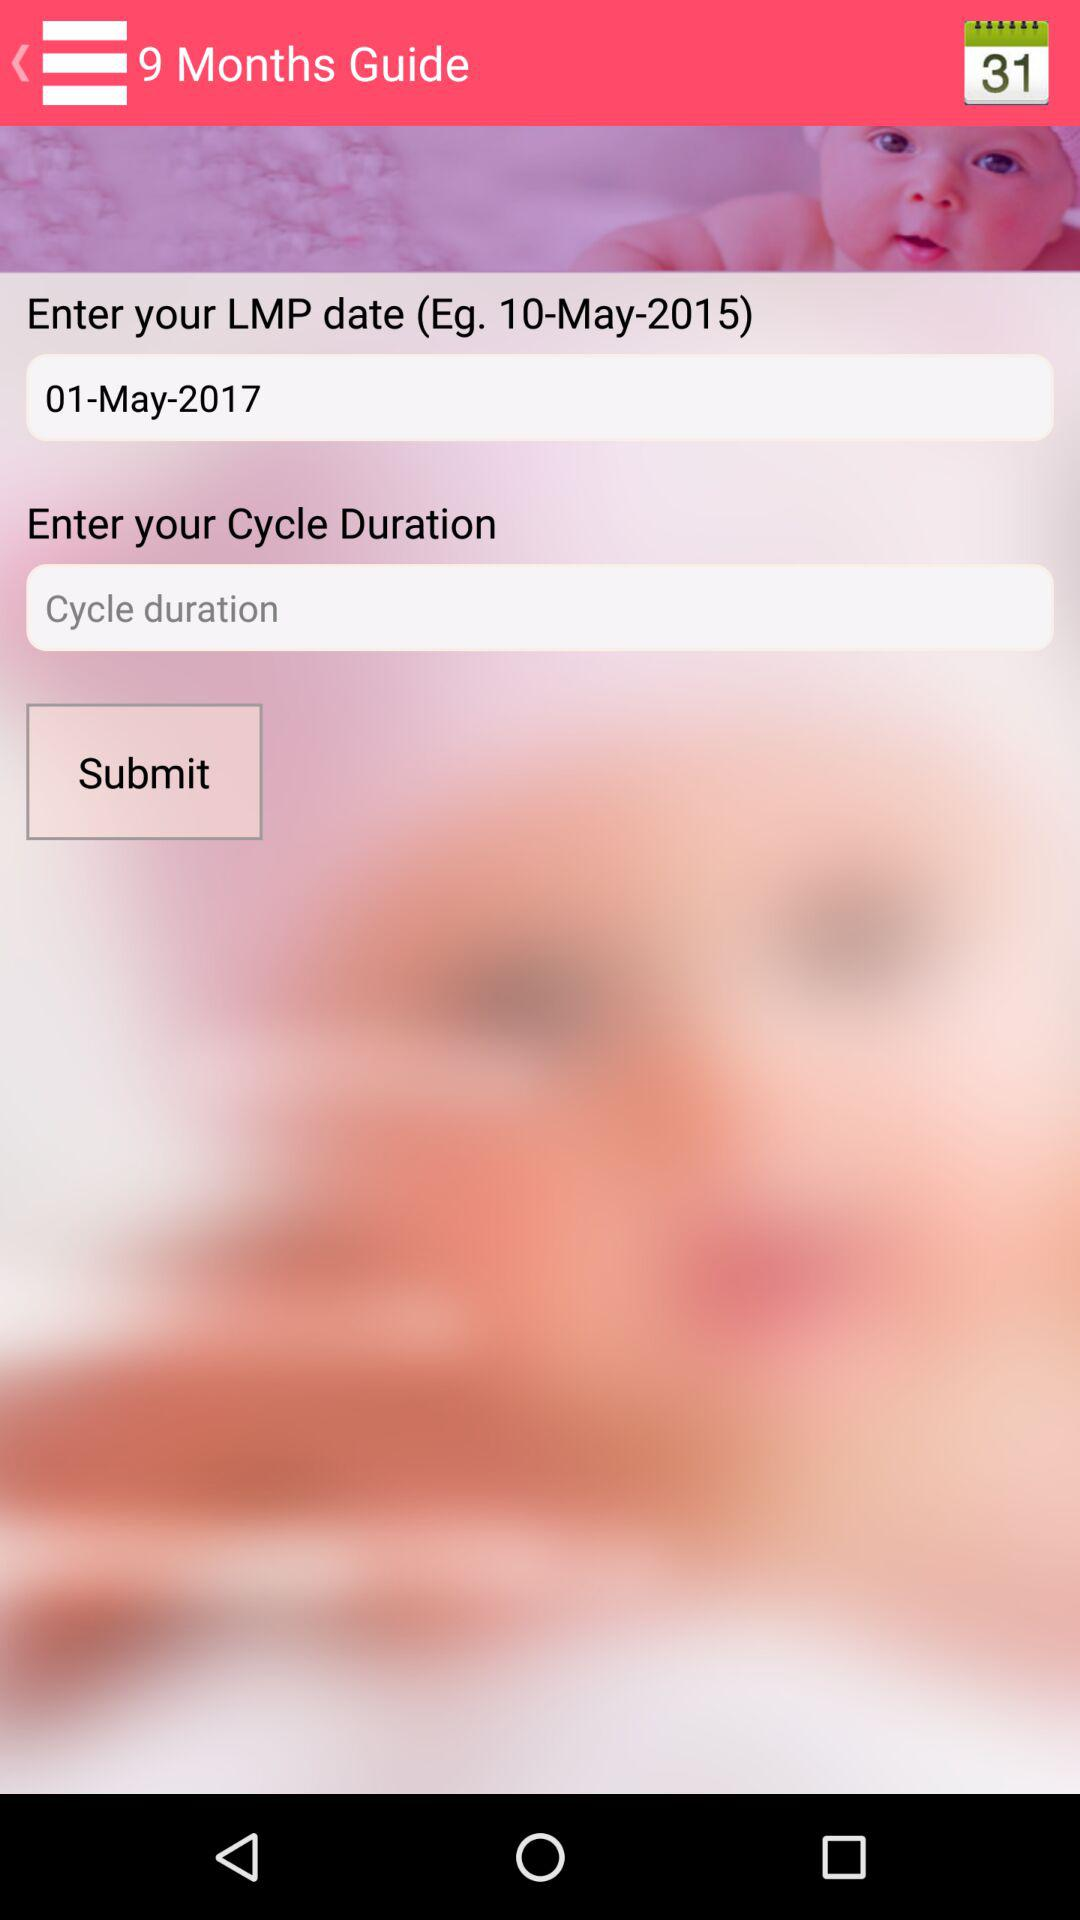What is the mentioned date on the calendar? The mentioned date is 31. 